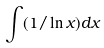Convert formula to latex. <formula><loc_0><loc_0><loc_500><loc_500>\int ( 1 / \ln x ) d x</formula> 